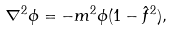<formula> <loc_0><loc_0><loc_500><loc_500>\nabla ^ { 2 } \phi = - m ^ { 2 } \phi ( 1 - { \hat { f } } ^ { 2 } ) ,</formula> 